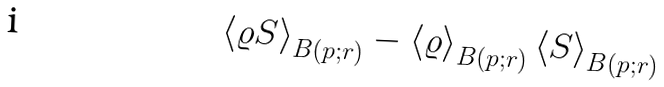<formula> <loc_0><loc_0><loc_500><loc_500>\left \langle \varrho S \right \rangle _ { B ( p ; r ) } - \left \langle \varrho \right \rangle _ { B ( p ; r ) } \left \langle S \right \rangle _ { B ( p ; r ) }</formula> 